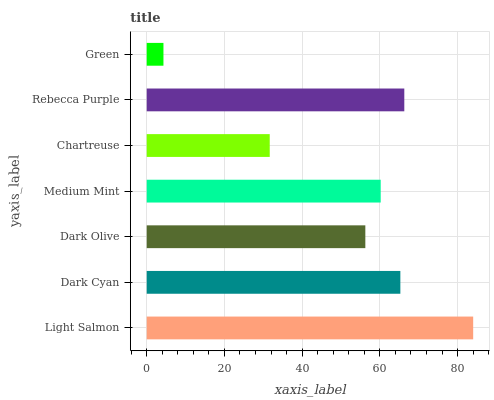Is Green the minimum?
Answer yes or no. Yes. Is Light Salmon the maximum?
Answer yes or no. Yes. Is Dark Cyan the minimum?
Answer yes or no. No. Is Dark Cyan the maximum?
Answer yes or no. No. Is Light Salmon greater than Dark Cyan?
Answer yes or no. Yes. Is Dark Cyan less than Light Salmon?
Answer yes or no. Yes. Is Dark Cyan greater than Light Salmon?
Answer yes or no. No. Is Light Salmon less than Dark Cyan?
Answer yes or no. No. Is Medium Mint the high median?
Answer yes or no. Yes. Is Medium Mint the low median?
Answer yes or no. Yes. Is Dark Olive the high median?
Answer yes or no. No. Is Dark Cyan the low median?
Answer yes or no. No. 